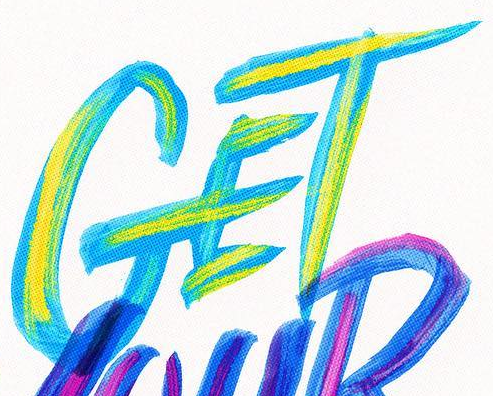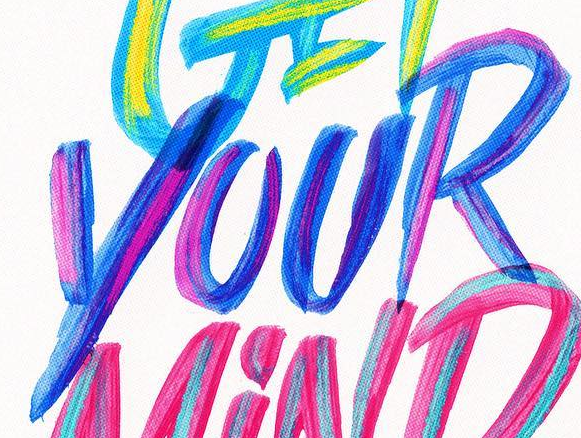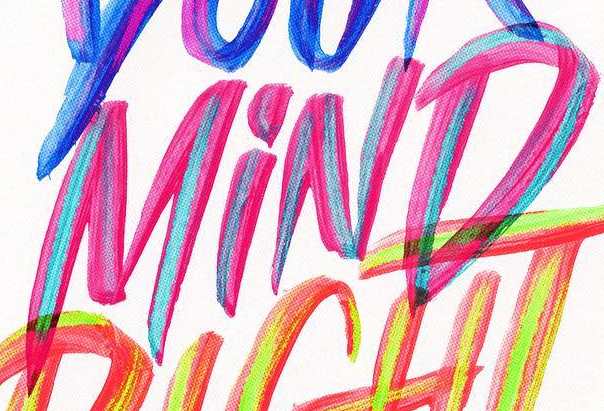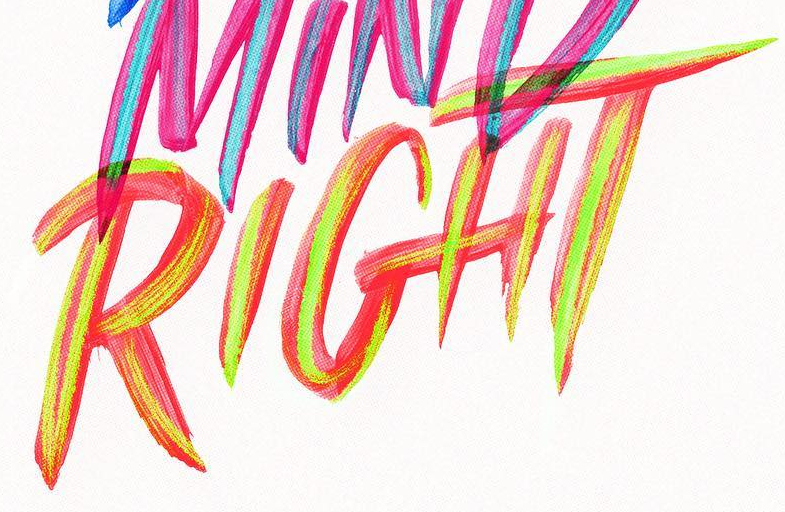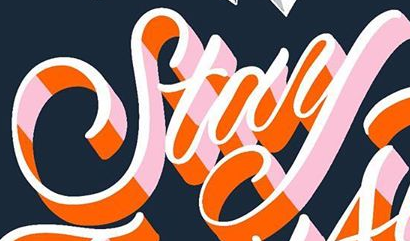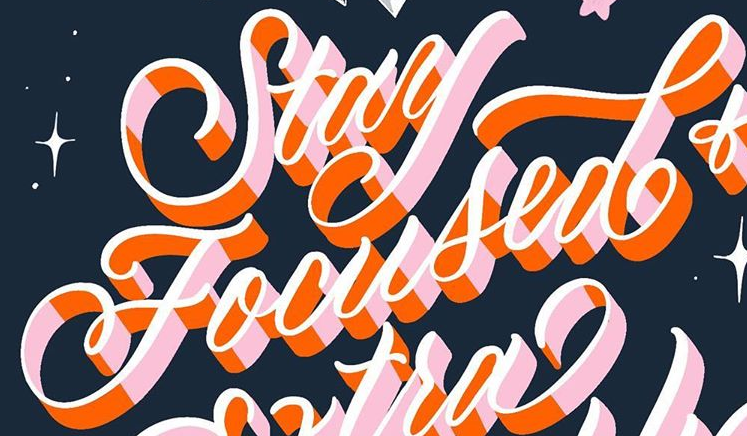What text appears in these images from left to right, separated by a semicolon? GET; YOUR; MiND; RIGHT; Stay; Focused 